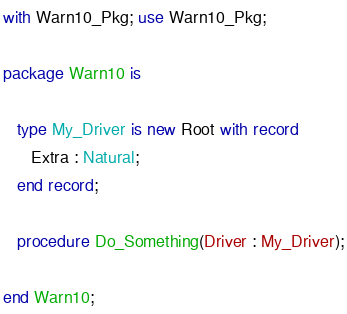Convert code to text. <code><loc_0><loc_0><loc_500><loc_500><_Ada_>with Warn10_Pkg; use Warn10_Pkg;

package Warn10 is

   type My_Driver is new Root with record
      Extra : Natural;
   end record;

   procedure Do_Something(Driver : My_Driver);

end Warn10;
</code> 